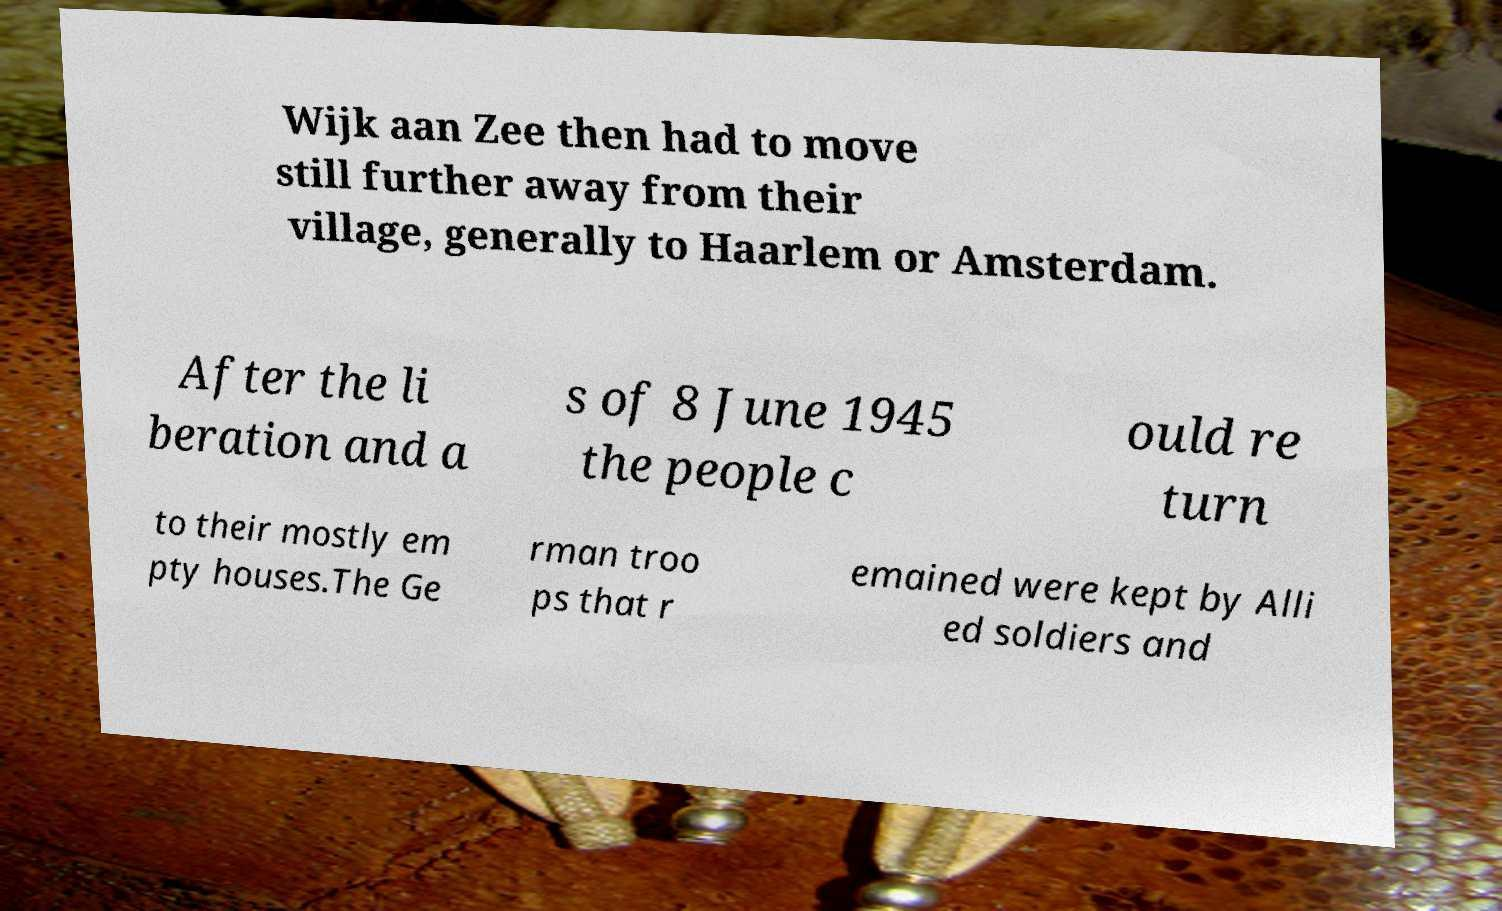I need the written content from this picture converted into text. Can you do that? Wijk aan Zee then had to move still further away from their village, generally to Haarlem or Amsterdam. After the li beration and a s of 8 June 1945 the people c ould re turn to their mostly em pty houses.The Ge rman troo ps that r emained were kept by Alli ed soldiers and 